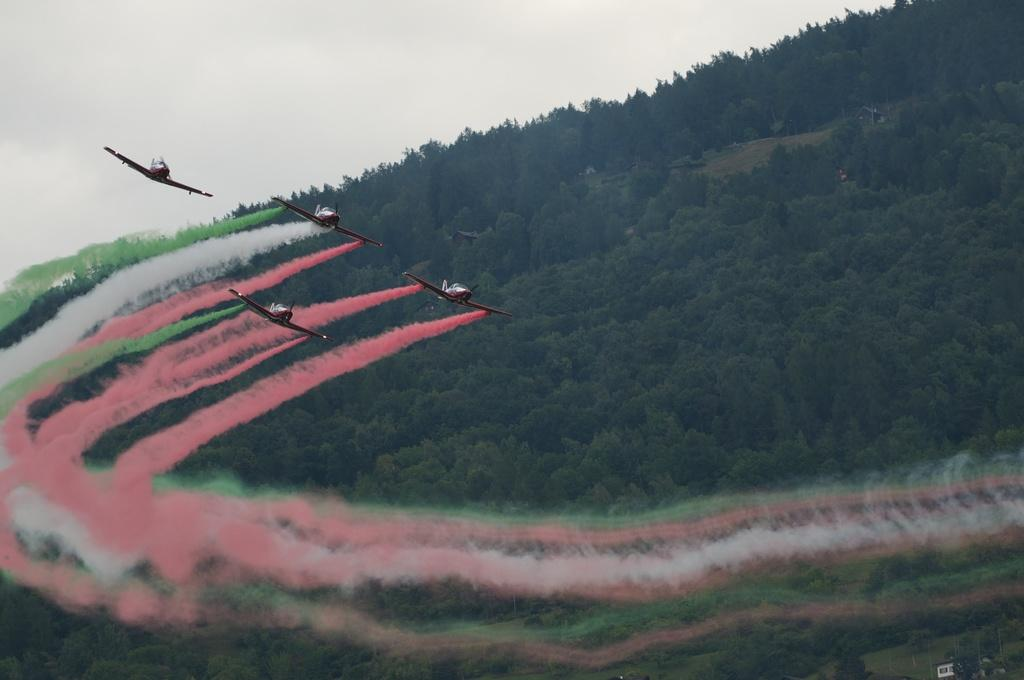What is happening in the sky in the image? There are planes in the air in the image. What can be seen in the distance in the image? There are trees visible in the background of the image. Where is the harbor located in the image? There is no harbor present in the image. What type of poison can be seen in the image? There is no poison present in the image. 